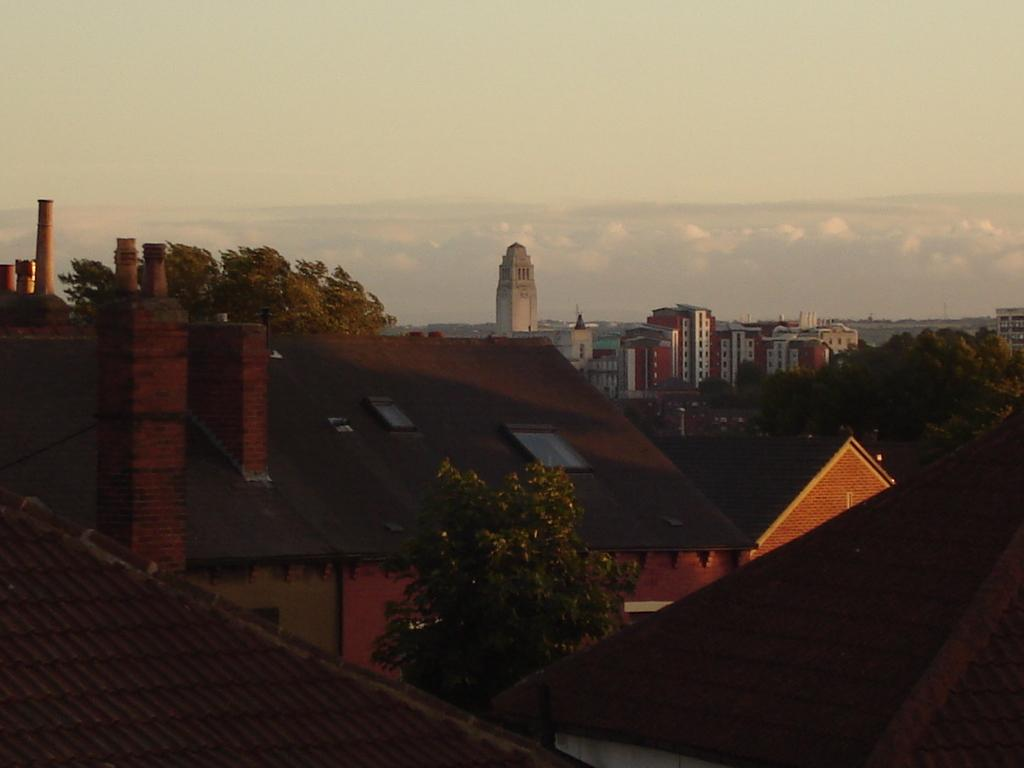What type of vegetation is present in the image? There are trees in the image. What is the color of the trees? The trees are green. What type of structures can be seen in the image? There are buildings in the image. What colors are the buildings? The buildings are in brown, white, and cream colors. What is visible in the background of the image? The sky in the background is white. What type of breakfast is being served on the trees in the image? There is no breakfast present in the image; it features trees and buildings. How many toes can be seen on the buildings in the image? There are no toes present in the image; it features trees and buildings. 